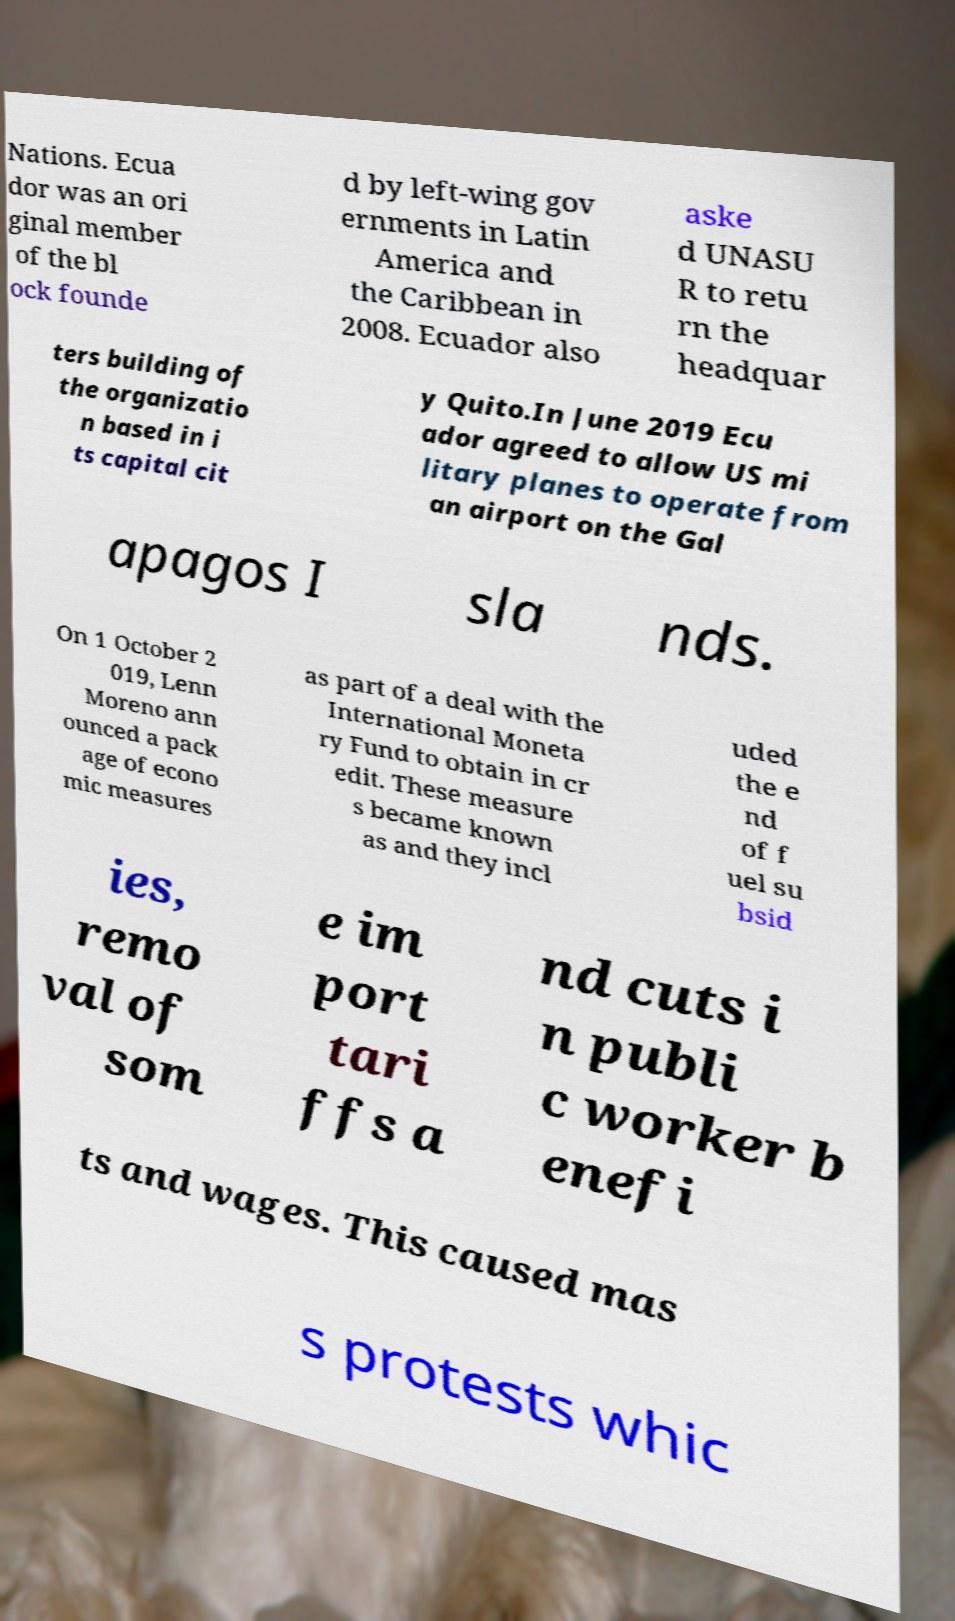Can you read and provide the text displayed in the image?This photo seems to have some interesting text. Can you extract and type it out for me? Nations. Ecua dor was an ori ginal member of the bl ock founde d by left-wing gov ernments in Latin America and the Caribbean in 2008. Ecuador also aske d UNASU R to retu rn the headquar ters building of the organizatio n based in i ts capital cit y Quito.In June 2019 Ecu ador agreed to allow US mi litary planes to operate from an airport on the Gal apagos I sla nds. On 1 October 2 019, Lenn Moreno ann ounced a pack age of econo mic measures as part of a deal with the International Moneta ry Fund to obtain in cr edit. These measure s became known as and they incl uded the e nd of f uel su bsid ies, remo val of som e im port tari ffs a nd cuts i n publi c worker b enefi ts and wages. This caused mas s protests whic 